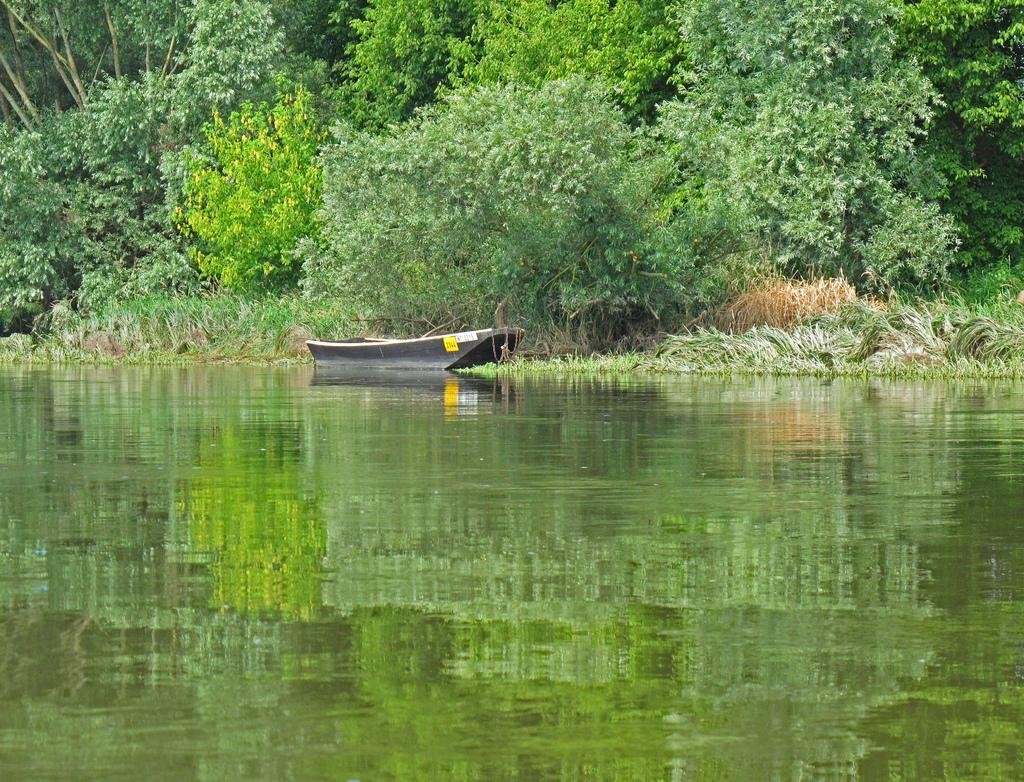What is the primary element visible in the image? There is water in the image. What type of boat can be seen in the water? There is a black-colored boat in the image. What can be seen in the background of the image? Trees are present in the background of the image. What brand of toothpaste is being advertised on the boat in the image? There is no toothpaste or advertisement present on the boat in the image. 